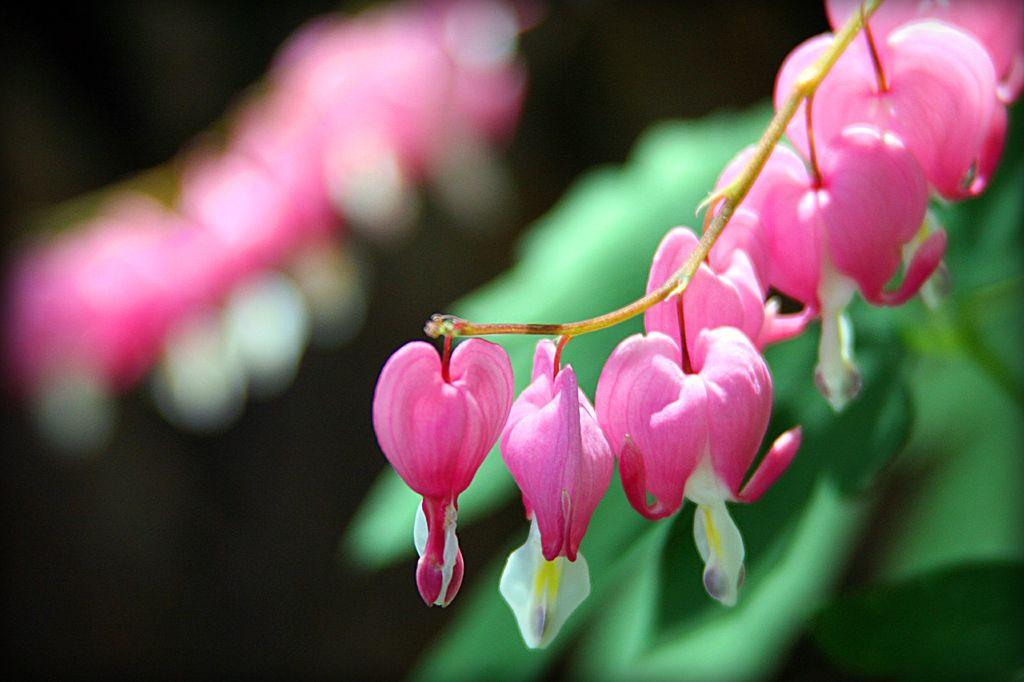What colors are the flowers in the image? The flowers in the image are pink and white. What colors can be seen in the background of the image? The background of the image includes green, pink, white, and black colors. How many square snails can be seen enjoying pleasure in the image? There are no snails, square or otherwise, present in the image, and therefore no such activity can be observed. 